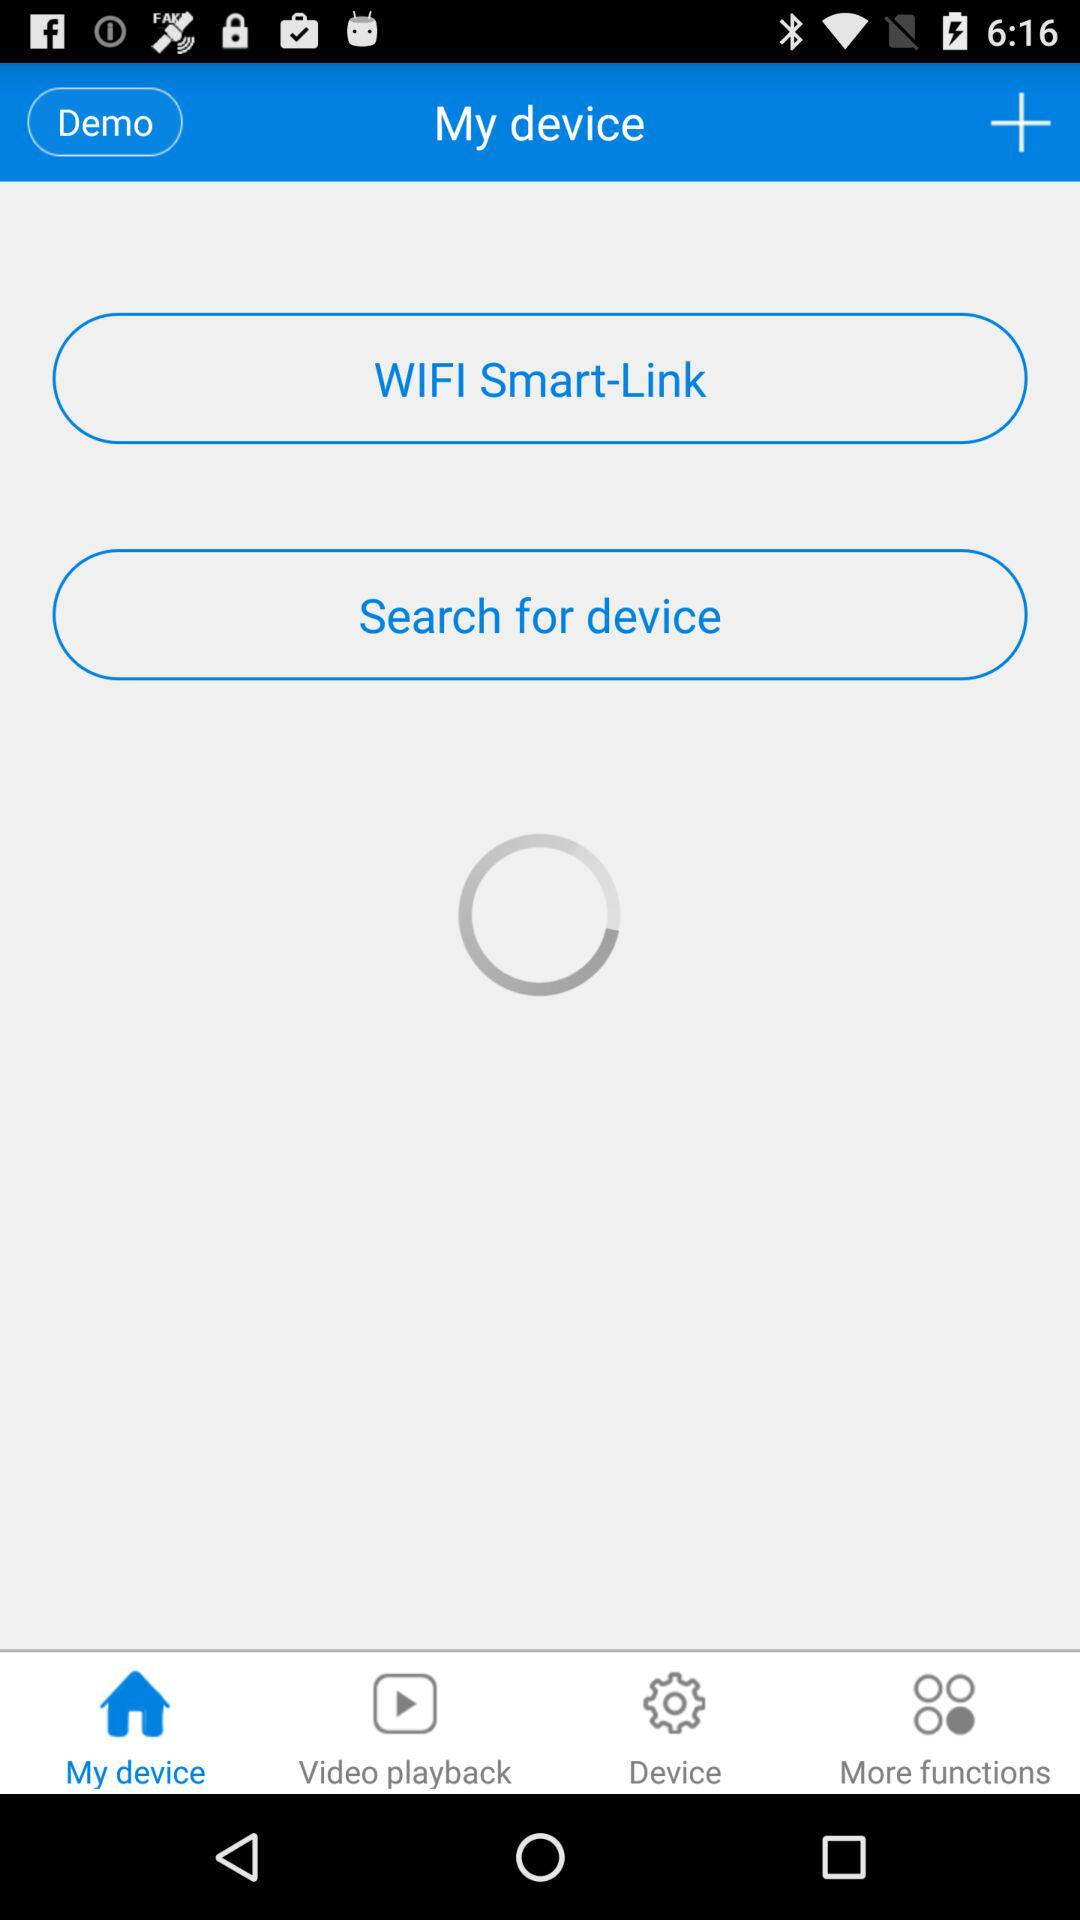Which tab is selected? The selected tab is "My device". 